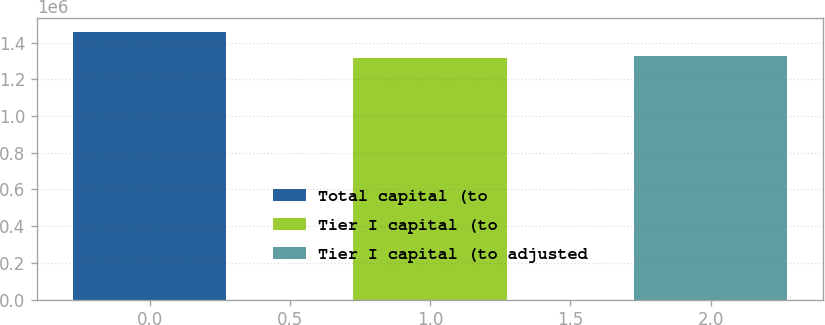Convert chart to OTSL. <chart><loc_0><loc_0><loc_500><loc_500><bar_chart><fcel>Total capital (to<fcel>Tier I capital (to<fcel>Tier I capital (to adjusted<nl><fcel>1.4609e+06<fcel>1.31437e+06<fcel>1.32903e+06<nl></chart> 